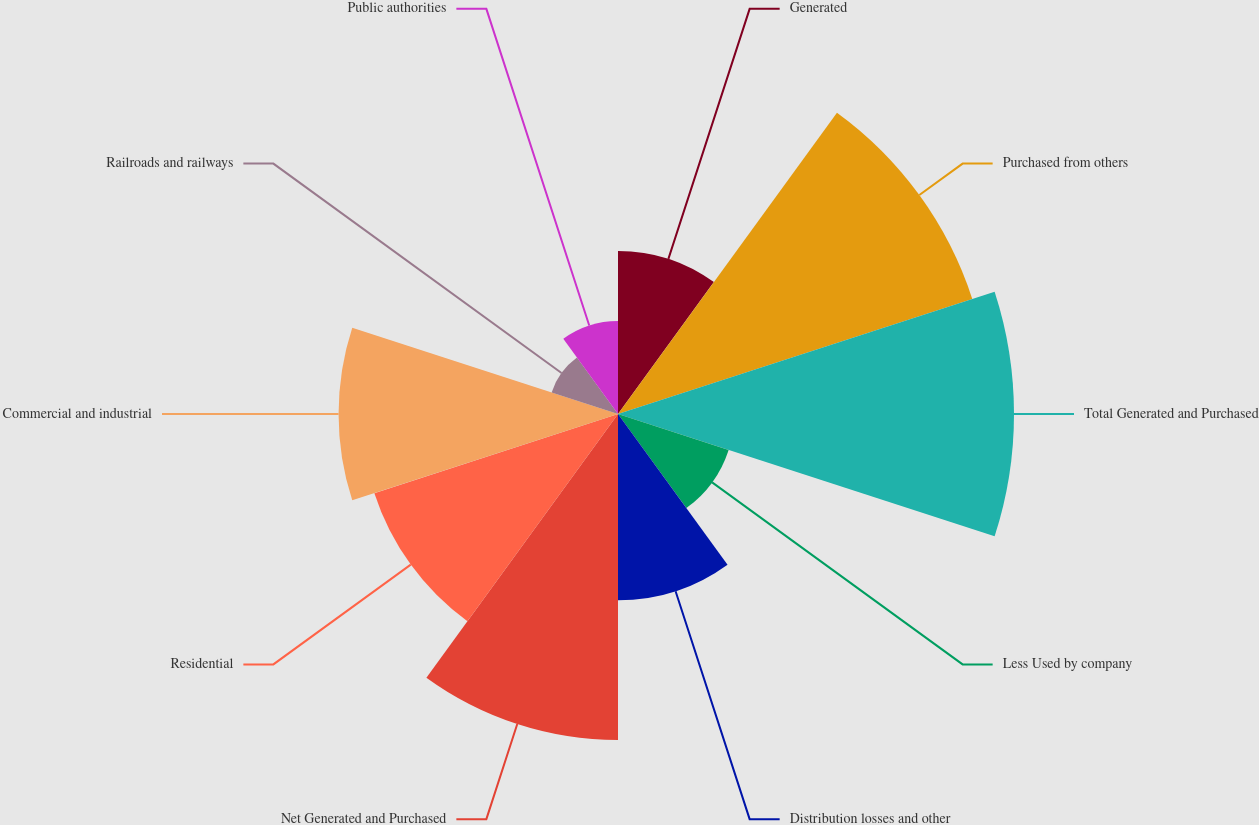Convert chart. <chart><loc_0><loc_0><loc_500><loc_500><pie_chart><fcel>Generated<fcel>Purchased from others<fcel>Total Generated and Purchased<fcel>Less Used by company<fcel>Distribution losses and other<fcel>Net Generated and Purchased<fcel>Residential<fcel>Commercial and industrial<fcel>Railroads and railways<fcel>Public authorities<nl><fcel>7.22%<fcel>16.49%<fcel>17.53%<fcel>5.15%<fcel>8.25%<fcel>14.43%<fcel>11.34%<fcel>12.37%<fcel>3.09%<fcel>4.12%<nl></chart> 